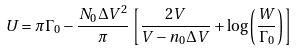<formula> <loc_0><loc_0><loc_500><loc_500>U = \pi \Gamma _ { 0 } - \frac { N _ { 0 } \Delta V ^ { 2 } } { \pi } \left [ \frac { 2 V } { V - n _ { 0 } \Delta V } + \log \left ( \frac { W } { \Gamma _ { 0 } } \right ) \right ]</formula> 